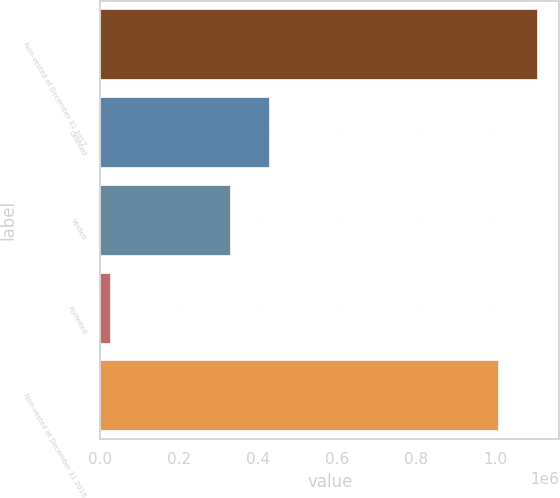<chart> <loc_0><loc_0><loc_500><loc_500><bar_chart><fcel>Non-vested at December 31 2017<fcel>Granted<fcel>Vested<fcel>Forfeited<fcel>Non-vested at December 31 2018<nl><fcel>1.10624e+06<fcel>427474<fcel>327069<fcel>24877<fcel>1.00584e+06<nl></chart> 